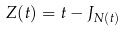Convert formula to latex. <formula><loc_0><loc_0><loc_500><loc_500>Z ( t ) = t - J _ { N ( t ) }</formula> 